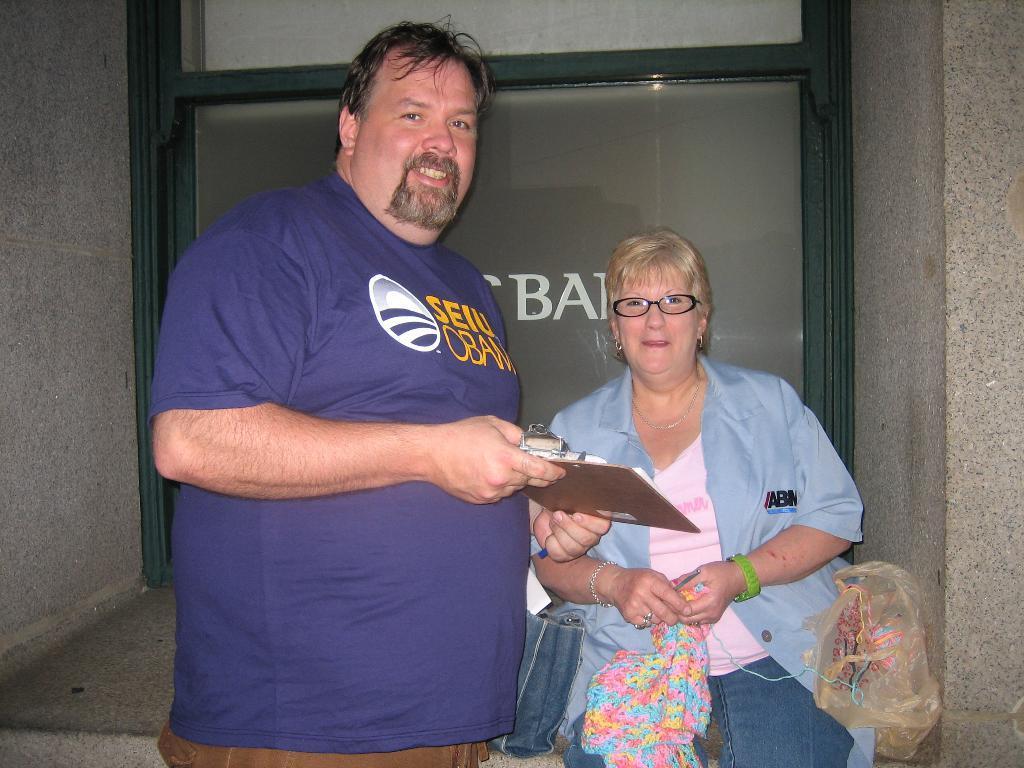Can you describe this image briefly? This image is taken outdoors. In the background there is a building with a few walls and a window. In the middle of the image a woman is sitting on the wall and a man is standing on the floor and he is holding a wooden pad in his hands. 